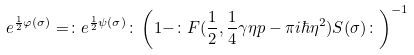Convert formula to latex. <formula><loc_0><loc_0><loc_500><loc_500>e ^ { \frac { 1 } { 2 } \varphi ( \sigma ) } = \colon e ^ { \frac { 1 } { 2 } \psi ( \sigma ) } \colon \left ( 1 - \colon F ( \frac { 1 } { 2 } , \frac { 1 } { 4 } \gamma \eta p - \pi i \hbar { \eta } ^ { 2 } ) S ( \sigma ) \colon \right ) ^ { - 1 }</formula> 